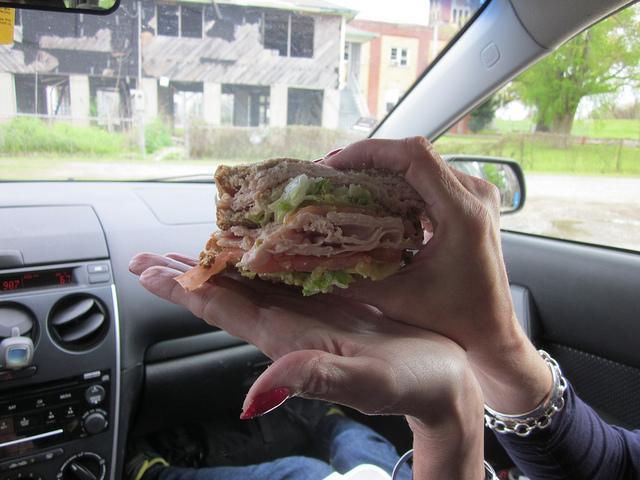Is a man or woman holding the sandwich?
Give a very brief answer. Woman. Is that sandwich tasty?
Quick response, please. Yes. Does she have painted nails?
Short answer required. Yes. 